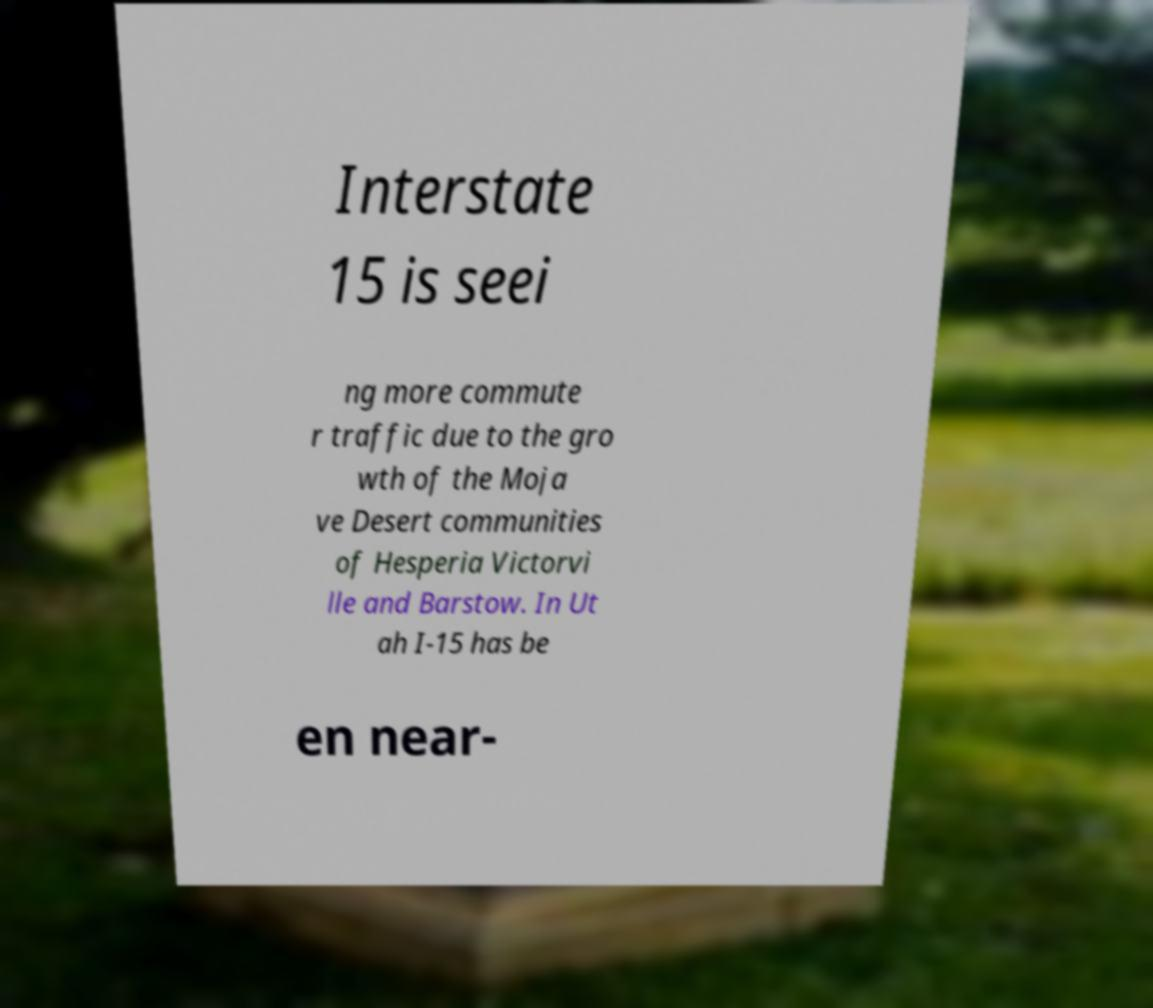I need the written content from this picture converted into text. Can you do that? Interstate 15 is seei ng more commute r traffic due to the gro wth of the Moja ve Desert communities of Hesperia Victorvi lle and Barstow. In Ut ah I-15 has be en near- 